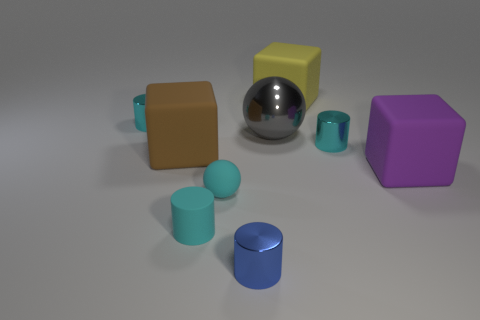Can you tell me about the lighting in the scene? The scene is illuminated by what appears to be a single, diffuse light source coming from above, casting soft shadows beneath the objects, indicating a gentle and somewhat ambient lighting setup, which enhances the three-dimensional feel of the objects. Does the lighting affect the colors of the objects? Yes, the lighting subtly affects the colors, making them appear softer and less saturated. It also influences the visibility of surface details and textures, particularly noticeable on the objects with more tactile surfaces. 